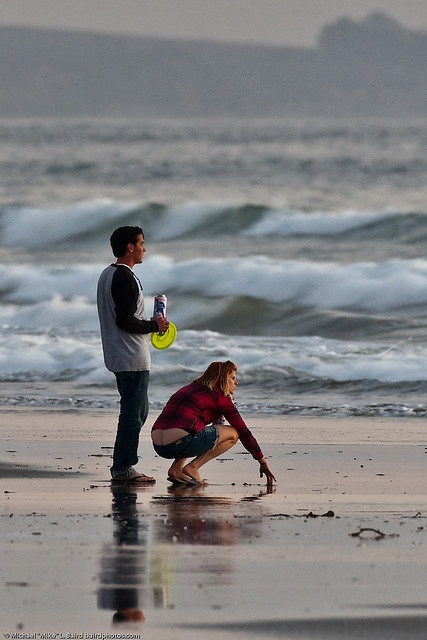Describe the objects in this image and their specific colors. I can see people in gray, black, and maroon tones and frisbee in gray, olive, gold, and khaki tones in this image. 